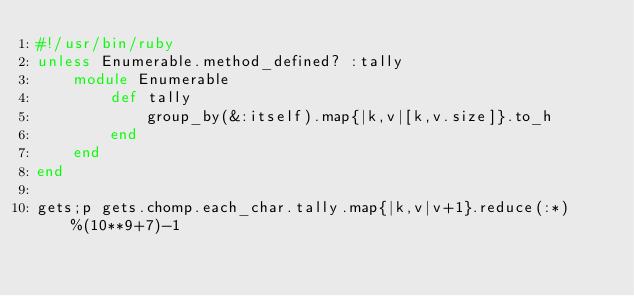Convert code to text. <code><loc_0><loc_0><loc_500><loc_500><_Ruby_>#!/usr/bin/ruby
unless Enumerable.method_defined? :tally
	module Enumerable
		def tally
			group_by(&:itself).map{|k,v|[k,v.size]}.to_h
		end
	end
end

gets;p gets.chomp.each_char.tally.map{|k,v|v+1}.reduce(:*)%(10**9+7)-1</code> 